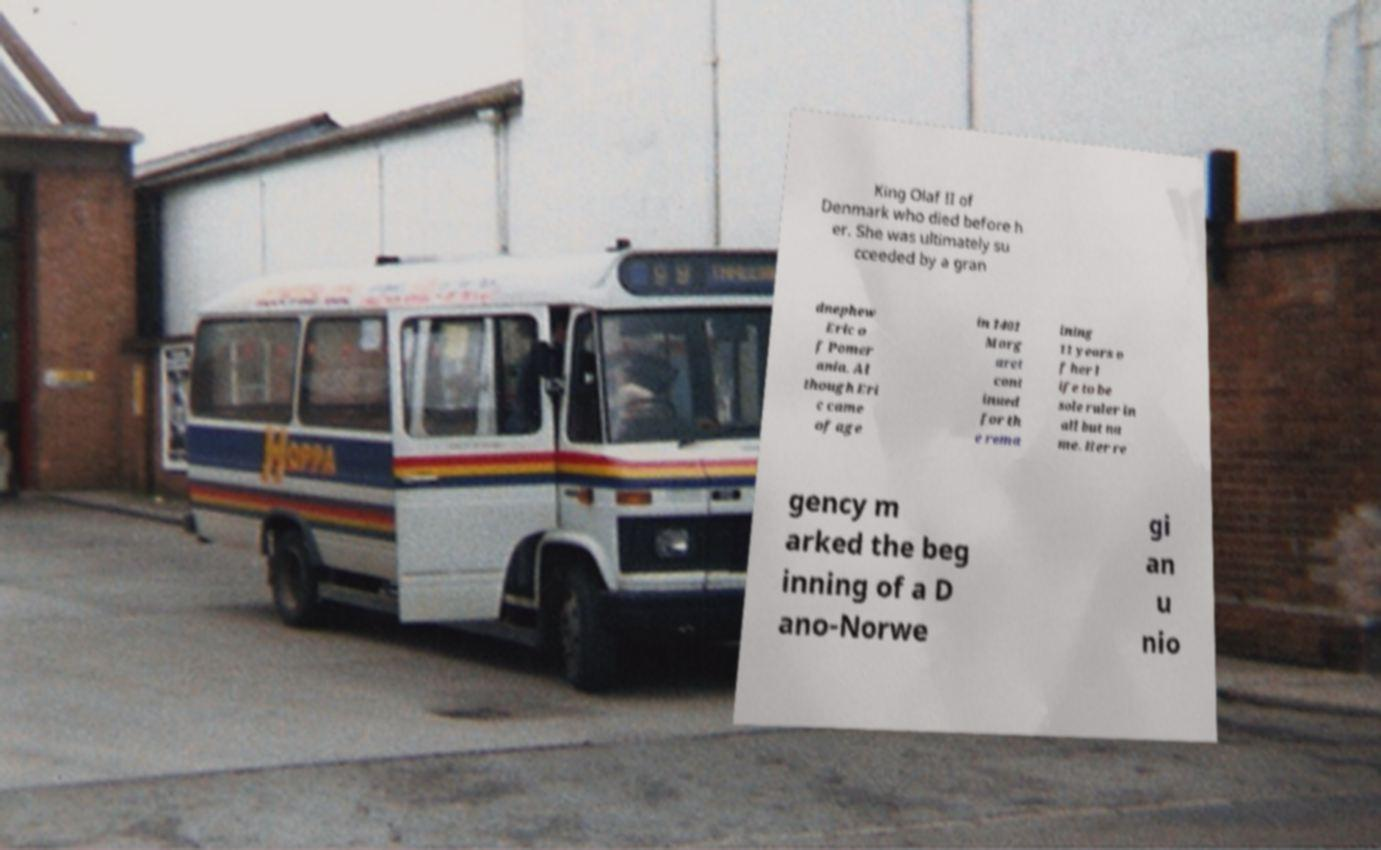For documentation purposes, I need the text within this image transcribed. Could you provide that? King Olaf II of Denmark who died before h er. She was ultimately su cceeded by a gran dnephew Eric o f Pomer ania. Al though Eri c came of age in 1401 Marg aret cont inued for th e rema ining 11 years o f her l ife to be sole ruler in all but na me. Her re gency m arked the beg inning of a D ano-Norwe gi an u nio 